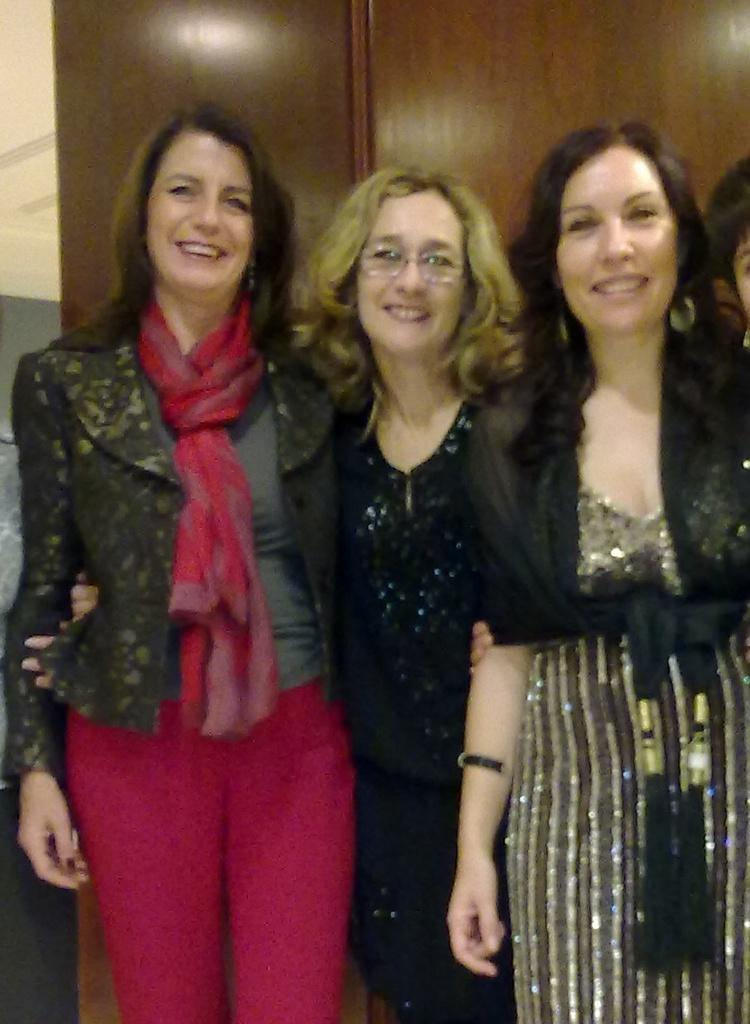What can be seen in the image? There are people standing in the image. What is located in the background of the image? There is a cupboard in the background of the image. What else is visible in the image? There is a wall visible in the image. What type of flag can be seen waving in the image? There is no flag present in the image. What is the weather like in the image, considering the presence of thunder? There is no mention of thunder in the image, so it cannot be determined from the image. 